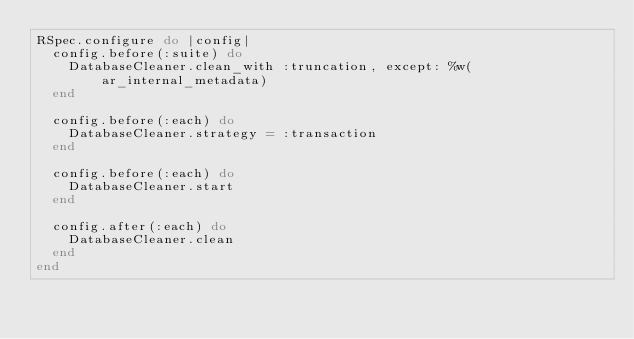Convert code to text. <code><loc_0><loc_0><loc_500><loc_500><_Ruby_>RSpec.configure do |config|
  config.before(:suite) do
    DatabaseCleaner.clean_with :truncation, except: %w(ar_internal_metadata)
  end

  config.before(:each) do
    DatabaseCleaner.strategy = :transaction
  end

  config.before(:each) do
    DatabaseCleaner.start
  end

  config.after(:each) do
    DatabaseCleaner.clean
  end
end
</code> 